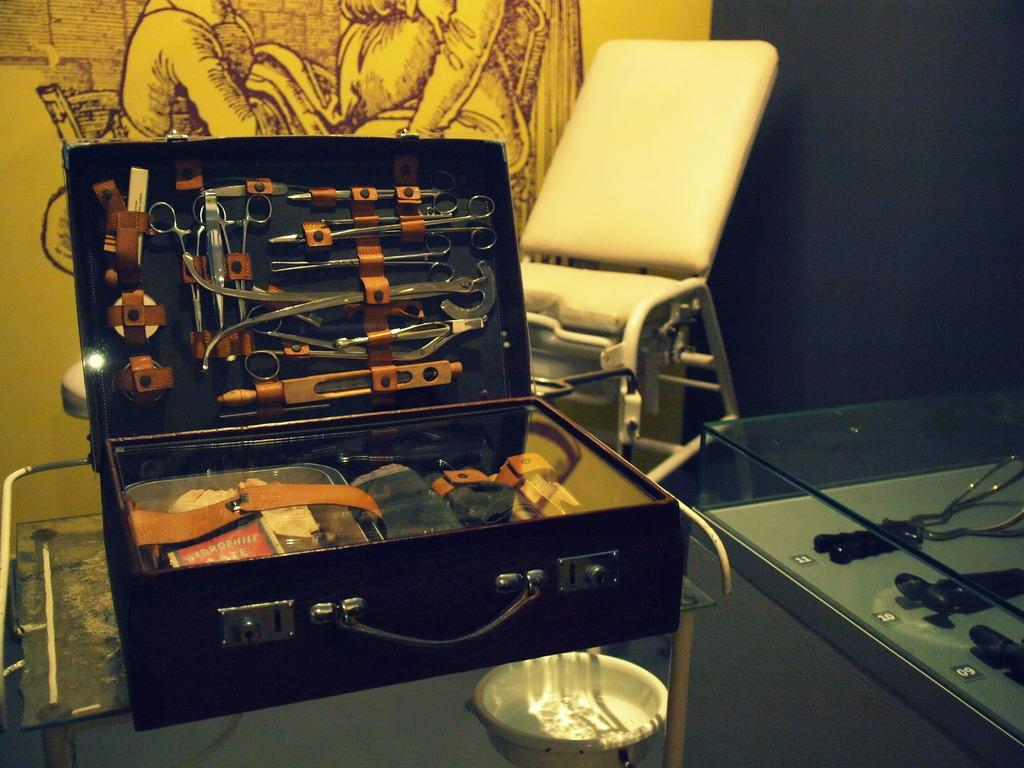What is the main object in the image? There is a box in the image. What is inside the box? The box contains different types of tools. What piece of furniture is present in the image? There is a chair in the image. What type of artwork can be seen in the image? There is a painting on a wall in the image. Can you describe the white object in the image? There is a white object in the image, but its specific details are not mentioned in the facts. Can you tell me how many plates are on the sidewalk in the image? There is no mention of plates or sidewalks in the image, so we cannot answer this question. 